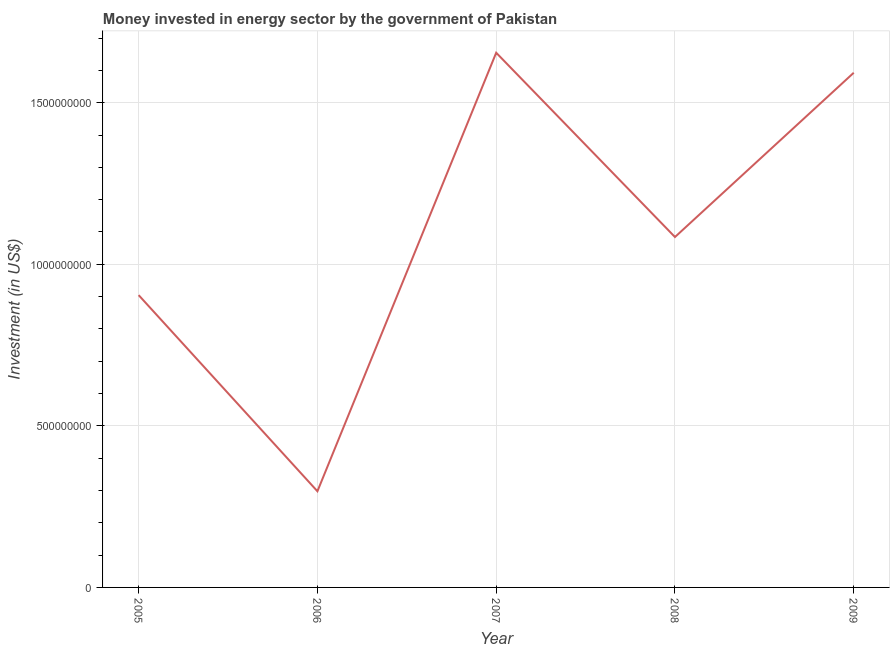What is the investment in energy in 2005?
Ensure brevity in your answer.  9.05e+08. Across all years, what is the maximum investment in energy?
Provide a short and direct response. 1.65e+09. Across all years, what is the minimum investment in energy?
Provide a succinct answer. 2.98e+08. In which year was the investment in energy minimum?
Make the answer very short. 2006. What is the sum of the investment in energy?
Your answer should be compact. 5.53e+09. What is the difference between the investment in energy in 2005 and 2008?
Keep it short and to the point. -1.80e+08. What is the average investment in energy per year?
Your answer should be compact. 1.11e+09. What is the median investment in energy?
Offer a very short reply. 1.08e+09. Do a majority of the years between 2006 and 2008 (inclusive) have investment in energy greater than 900000000 US$?
Your answer should be very brief. Yes. What is the ratio of the investment in energy in 2007 to that in 2008?
Ensure brevity in your answer.  1.53. Is the investment in energy in 2005 less than that in 2006?
Give a very brief answer. No. Is the difference between the investment in energy in 2005 and 2008 greater than the difference between any two years?
Make the answer very short. No. What is the difference between the highest and the second highest investment in energy?
Make the answer very short. 6.19e+07. Is the sum of the investment in energy in 2008 and 2009 greater than the maximum investment in energy across all years?
Your answer should be compact. Yes. What is the difference between the highest and the lowest investment in energy?
Your answer should be compact. 1.36e+09. How many lines are there?
Make the answer very short. 1. How many years are there in the graph?
Keep it short and to the point. 5. What is the difference between two consecutive major ticks on the Y-axis?
Keep it short and to the point. 5.00e+08. Are the values on the major ticks of Y-axis written in scientific E-notation?
Give a very brief answer. No. Does the graph contain any zero values?
Offer a very short reply. No. What is the title of the graph?
Give a very brief answer. Money invested in energy sector by the government of Pakistan. What is the label or title of the X-axis?
Give a very brief answer. Year. What is the label or title of the Y-axis?
Give a very brief answer. Investment (in US$). What is the Investment (in US$) of 2005?
Ensure brevity in your answer.  9.05e+08. What is the Investment (in US$) of 2006?
Keep it short and to the point. 2.98e+08. What is the Investment (in US$) of 2007?
Your answer should be very brief. 1.65e+09. What is the Investment (in US$) of 2008?
Offer a very short reply. 1.08e+09. What is the Investment (in US$) of 2009?
Provide a succinct answer. 1.59e+09. What is the difference between the Investment (in US$) in 2005 and 2006?
Offer a very short reply. 6.07e+08. What is the difference between the Investment (in US$) in 2005 and 2007?
Provide a short and direct response. -7.50e+08. What is the difference between the Investment (in US$) in 2005 and 2008?
Offer a very short reply. -1.80e+08. What is the difference between the Investment (in US$) in 2005 and 2009?
Provide a short and direct response. -6.88e+08. What is the difference between the Investment (in US$) in 2006 and 2007?
Give a very brief answer. -1.36e+09. What is the difference between the Investment (in US$) in 2006 and 2008?
Give a very brief answer. -7.87e+08. What is the difference between the Investment (in US$) in 2006 and 2009?
Your response must be concise. -1.30e+09. What is the difference between the Investment (in US$) in 2007 and 2008?
Your answer should be very brief. 5.70e+08. What is the difference between the Investment (in US$) in 2007 and 2009?
Keep it short and to the point. 6.19e+07. What is the difference between the Investment (in US$) in 2008 and 2009?
Ensure brevity in your answer.  -5.08e+08. What is the ratio of the Investment (in US$) in 2005 to that in 2006?
Your response must be concise. 3.04. What is the ratio of the Investment (in US$) in 2005 to that in 2007?
Your answer should be compact. 0.55. What is the ratio of the Investment (in US$) in 2005 to that in 2008?
Ensure brevity in your answer.  0.83. What is the ratio of the Investment (in US$) in 2005 to that in 2009?
Your answer should be compact. 0.57. What is the ratio of the Investment (in US$) in 2006 to that in 2007?
Provide a succinct answer. 0.18. What is the ratio of the Investment (in US$) in 2006 to that in 2008?
Your answer should be very brief. 0.27. What is the ratio of the Investment (in US$) in 2006 to that in 2009?
Provide a short and direct response. 0.19. What is the ratio of the Investment (in US$) in 2007 to that in 2008?
Offer a terse response. 1.53. What is the ratio of the Investment (in US$) in 2007 to that in 2009?
Make the answer very short. 1.04. What is the ratio of the Investment (in US$) in 2008 to that in 2009?
Offer a terse response. 0.68. 